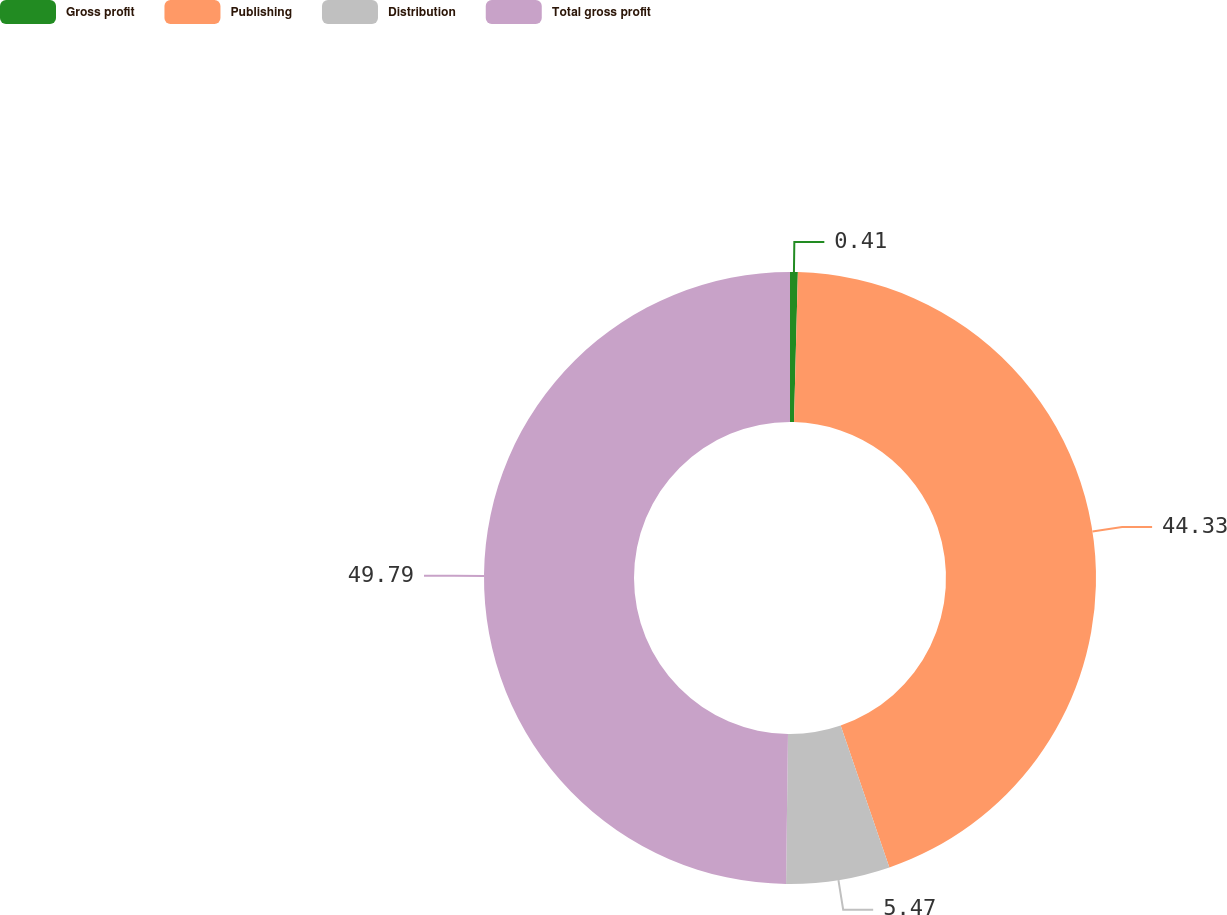<chart> <loc_0><loc_0><loc_500><loc_500><pie_chart><fcel>Gross profit<fcel>Publishing<fcel>Distribution<fcel>Total gross profit<nl><fcel>0.41%<fcel>44.33%<fcel>5.47%<fcel>49.8%<nl></chart> 